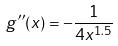<formula> <loc_0><loc_0><loc_500><loc_500>g ^ { \prime \prime } ( x ) = - \frac { 1 } { 4 x ^ { 1 . 5 } }</formula> 